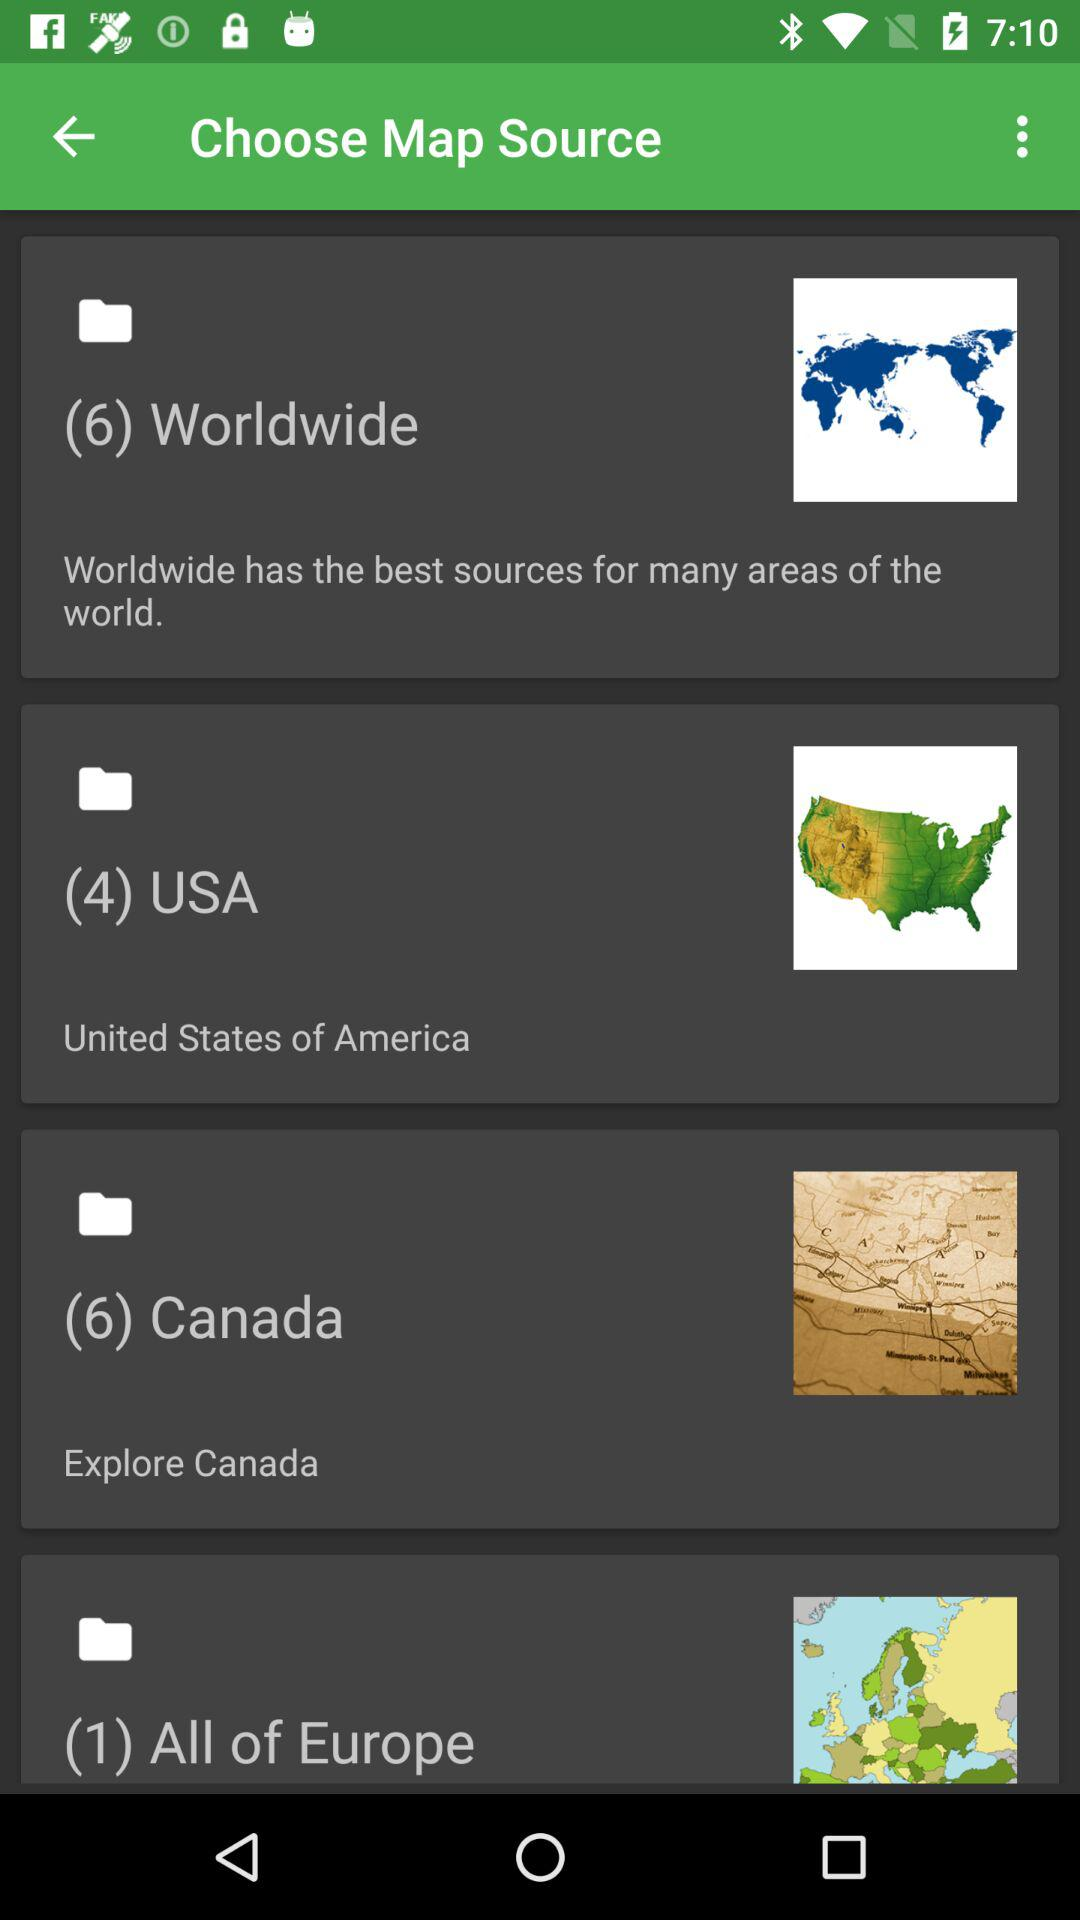What is the number of files in the United State of America folder? The number of files in the United State of America folder is 4. 